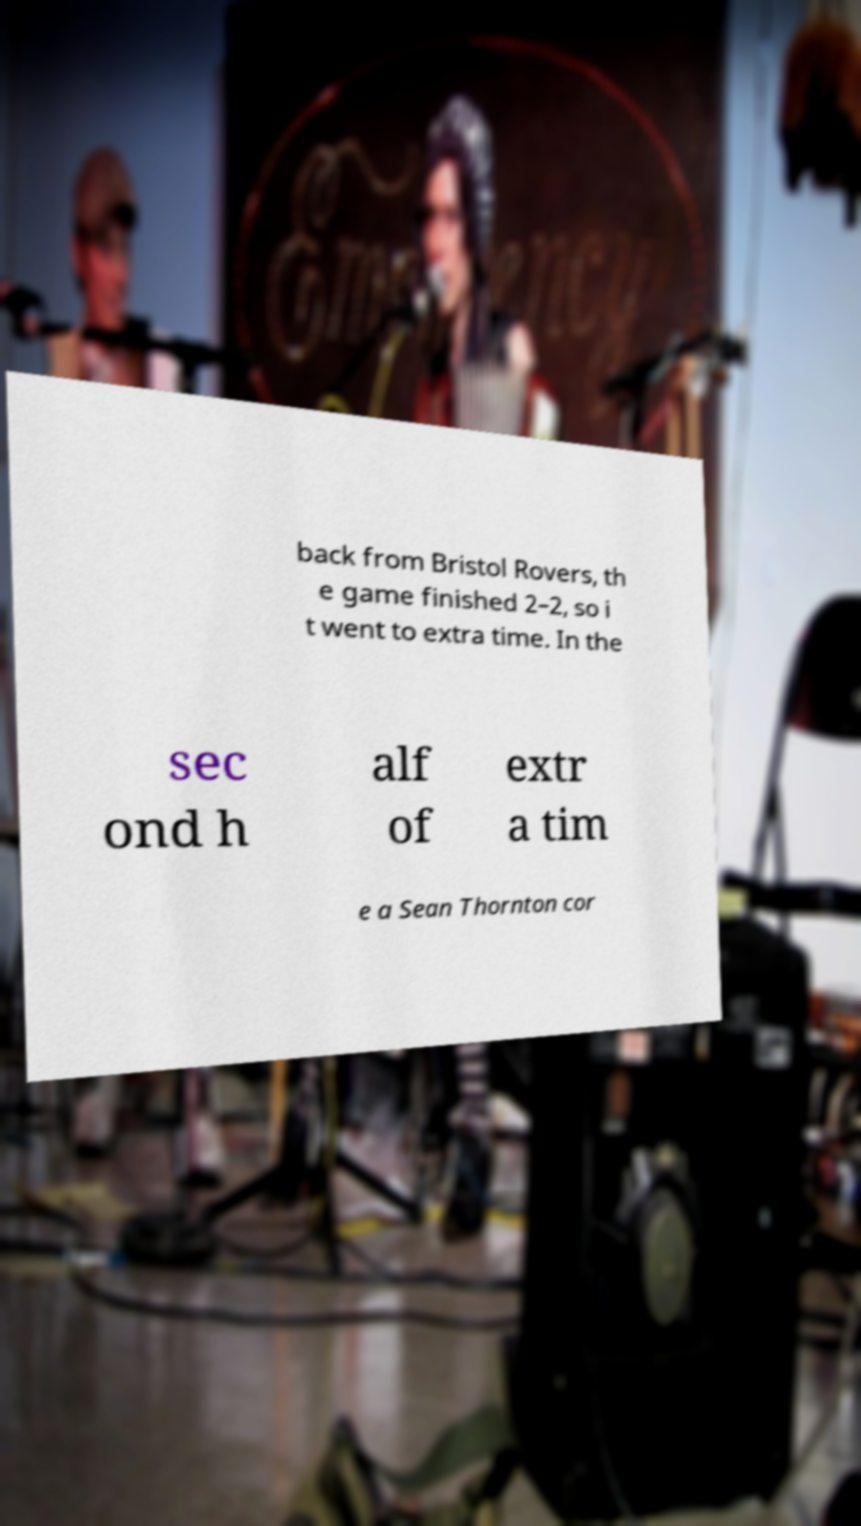Please read and relay the text visible in this image. What does it say? back from Bristol Rovers, th e game finished 2–2, so i t went to extra time. In the sec ond h alf of extr a tim e a Sean Thornton cor 